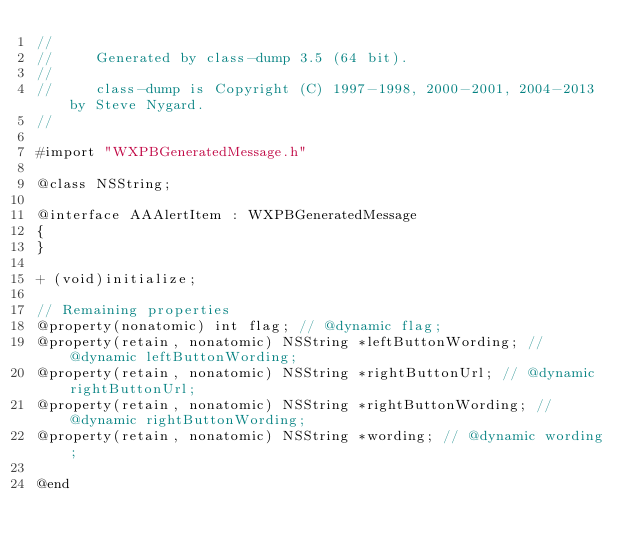Convert code to text. <code><loc_0><loc_0><loc_500><loc_500><_C_>//
//     Generated by class-dump 3.5 (64 bit).
//
//     class-dump is Copyright (C) 1997-1998, 2000-2001, 2004-2013 by Steve Nygard.
//

#import "WXPBGeneratedMessage.h"

@class NSString;

@interface AAAlertItem : WXPBGeneratedMessage
{
}

+ (void)initialize;

// Remaining properties
@property(nonatomic) int flag; // @dynamic flag;
@property(retain, nonatomic) NSString *leftButtonWording; // @dynamic leftButtonWording;
@property(retain, nonatomic) NSString *rightButtonUrl; // @dynamic rightButtonUrl;
@property(retain, nonatomic) NSString *rightButtonWording; // @dynamic rightButtonWording;
@property(retain, nonatomic) NSString *wording; // @dynamic wording;

@end

</code> 